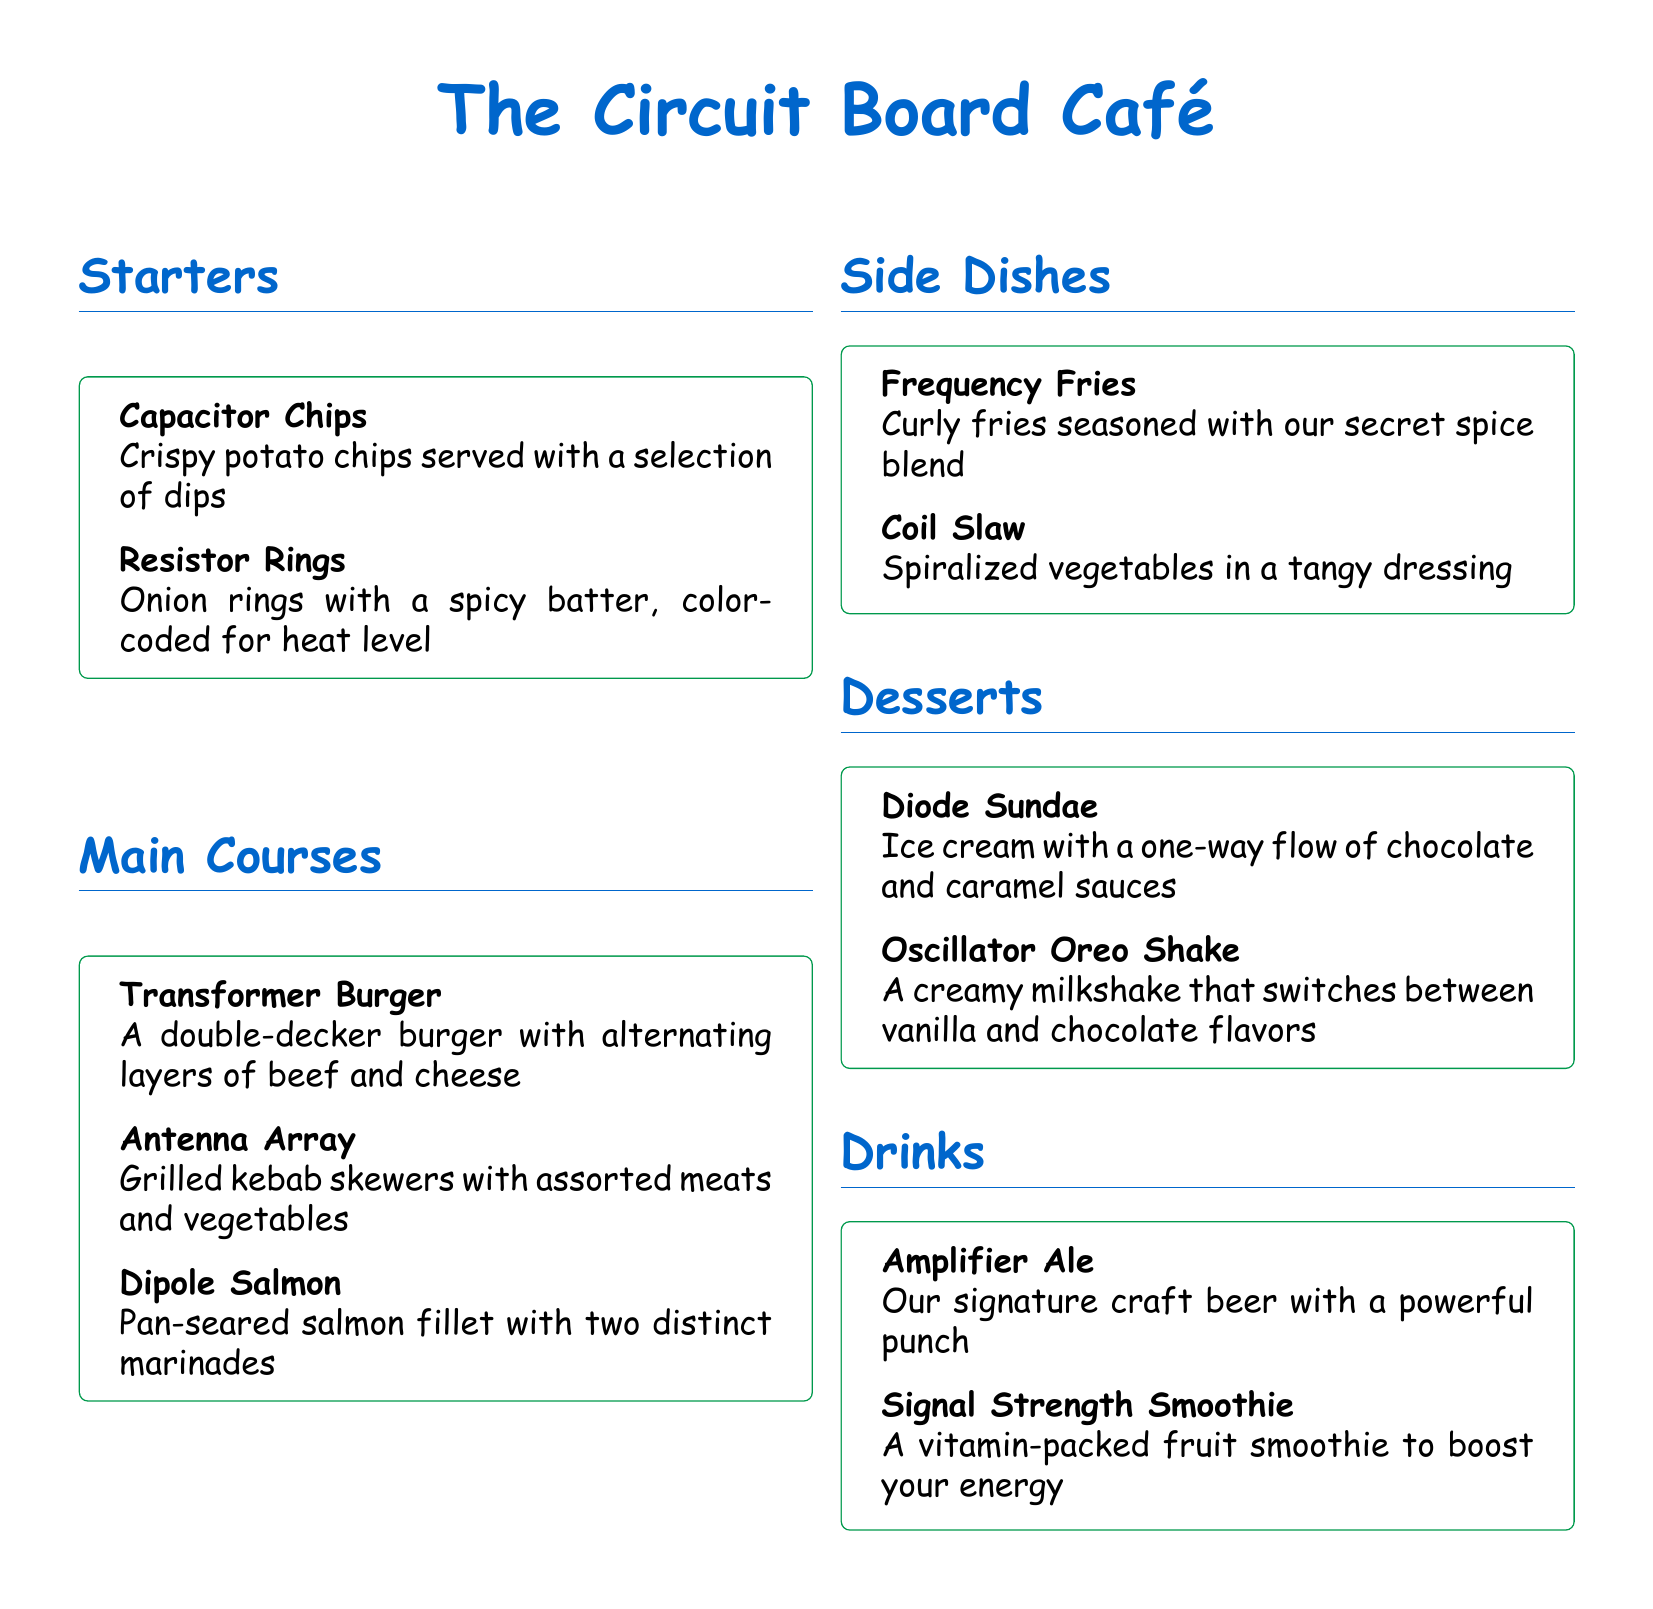what is the name of the café? The name of the café is prominently displayed at the top of the document.
Answer: The Circuit Board Café what are the starting dishes called? The section heading lists the items in the Starters category, which contains two specific dishes.
Answer: Starters how many main courses are listed? The main courses section contains three distinct dishes.
Answer: 3 what is the name of the dessert that includes ice cream? The dessert section has a specific entry that mentions ice cream.
Answer: Diode Sundae which drink is described as a craft beer? The drinks section contains a drink that is labeled with a specific term indicative of craft beer.
Answer: Amplifier Ale what are the components of the Transformer Burger? The Burger's description mentions two specific alternating ingredients found in it.
Answer: beef and cheese what type of vegetables are used in Coil Slaw? The side dish's description uses a specific term to describe the form of vegetables.
Answer: Spiralized which dish is associated with a one-way flow? The dessert section includes a dish that metaphorically refers to a one-way flow of sauces.
Answer: Diode Sundae which dish has a connection to kebabs? The main course section lists a dish that specifically mentions kebabs in its description.
Answer: Antenna Array 